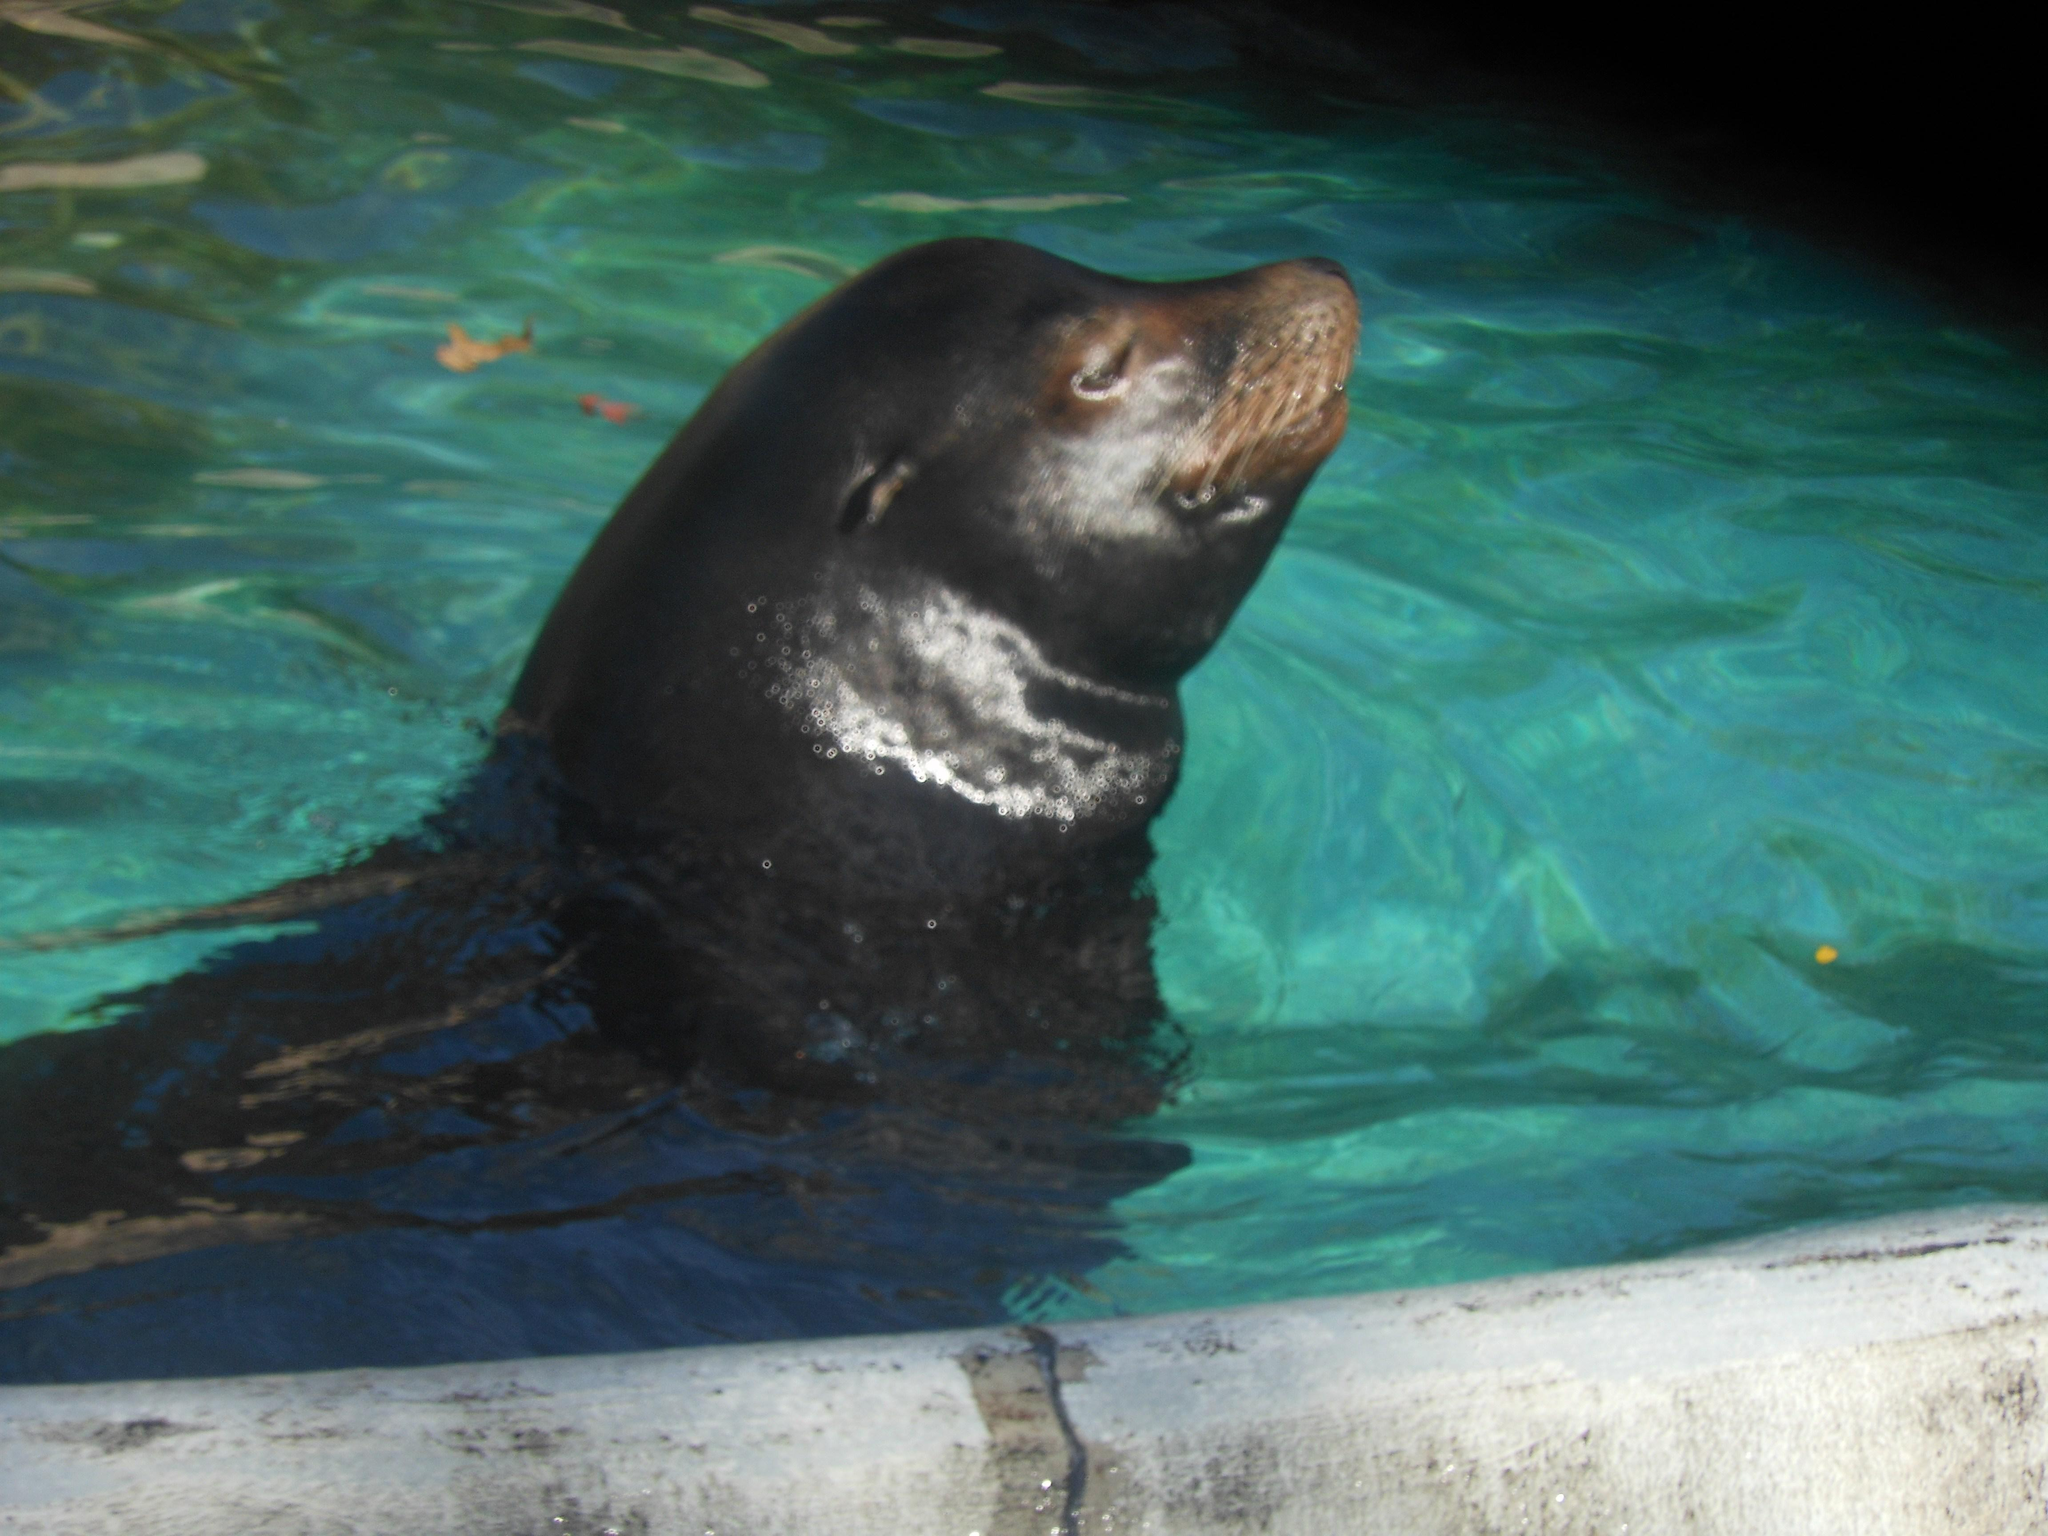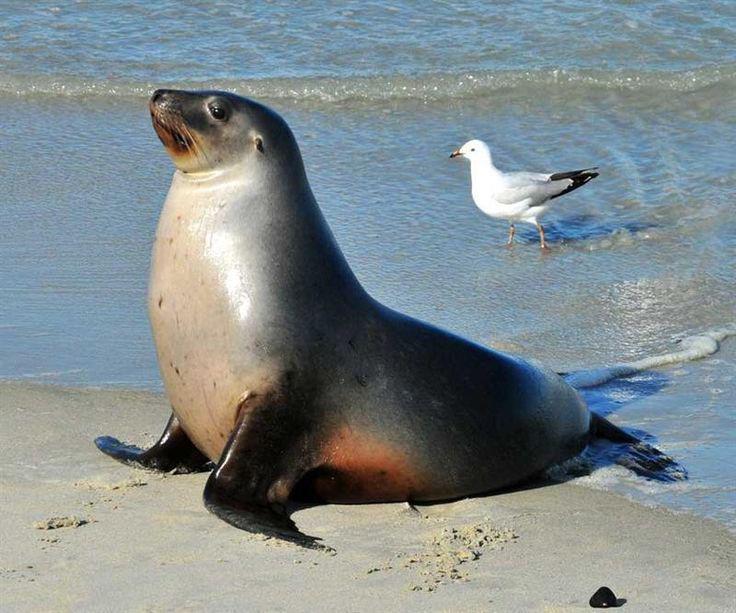The first image is the image on the left, the second image is the image on the right. Considering the images on both sides, is "The right image contains at least two seals." valid? Answer yes or no. No. The first image is the image on the left, the second image is the image on the right. Assess this claim about the two images: "Each image shows exactly one seal with raised head and water in the background, and one of the depicted seals faces left, while the other faces right.". Correct or not? Answer yes or no. Yes. 